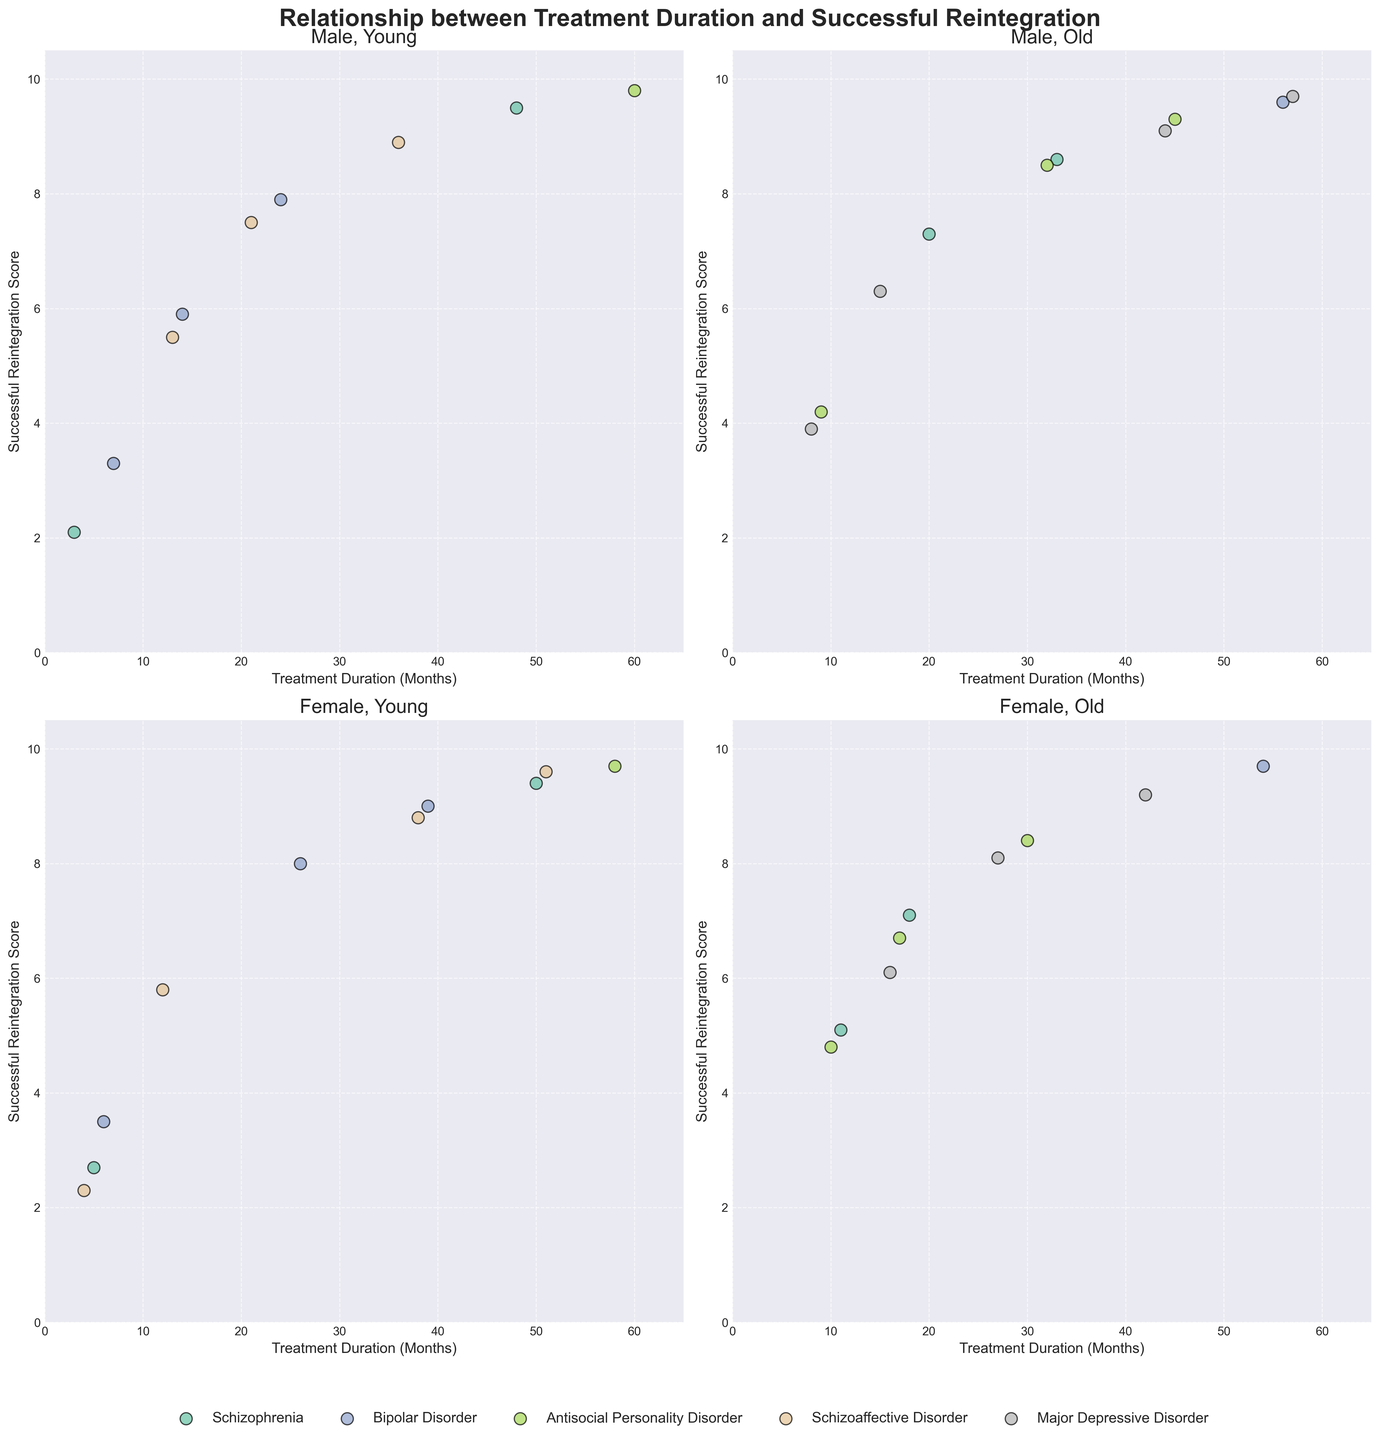Which age group for males shows a stronger correlation between treatment duration and reintegration success, Young or Old? Compare the spread and alignment of the data points from the male 'Young' and 'Old' subplots. The 'Old' age group in males shows a more consistent increase in reintegration success with longer treatment duration.
Answer: Old Comparing males and females in the Young age group, who has the highest reintegration score? Look at the highest points on the Young subplots for both males and females. The highest reintegration score in the male Young group is 9.7, and in the female Young group, it is also 9.7.
Answer: Both are equal For female patients, is there a significant difference in the successful reintegration score between Young and Old age groups for the same treatment duration? Examine overlapping treatment durations in the female 'Young' and 'Old' subplots to compare the reintegration scores. For example, at 9 months, the 'Young' female has a score of 4.2, while the 'Old' female at 8 months has a score of 8.0, indicating a significant difference.
Answer: Yes What is the overall trend of successful reintegration scores as treatment duration increases for the Old age group in both genders? Observe both subplots for the Old age group, noting the general direction of the data points along the x-axis. Both subplots show an increasing trend in reintegration scores with longer treatment duration.
Answer: Increase Which diagnosis shows the highest reintegration score for young female patients? Look for the highest data point in the young female subplot and identify its corresponding diagnosis. For young females, the highest score of 9.7 corresponds to Schizoaffective Disorder.
Answer: Schizoaffective Disorder Comparing the diagnoses represented in each subplot, which condition appears most frequently in the data? Count the occurrences of each diagnosis across all subplots. Schizophrenia appears most frequently in the data.
Answer: Schizophrenia Among patients with Antisocial Personality Disorder, do males or females have a higher maximum successful reintegration score? Identify the highest points for Antisocial Personality Disorder in both male and female subplots. The highest score for males is 9.8, while for females it is 9.7.
Answer: Males What is the average reintegration score for the Old female group? Sum the reintegration scores and divide by the number of data points for the 'Old' female subplot. Reintegration scores: 7.1, 8.4, 9.2, 9.5, 9.7, 9.6. Average = (7.1 + 8.4 + 9.2 + 9.5 + 9.7 + 9.6) / 6 = 8.9
Answer: 8.9 Does the reintegration score reach a plateau for young male patients after a certain treatment duration? Analyze the young male subplot for any plateau in scores as treatment duration increases. The scores generally increase without a clear plateau, suggesting continuous improvement.
Answer: No By how much does the reintegration score of young females increase between the shortest and longest treatment durations? Compare the scores at the shortest (3 months) and longest (60 months) durations for young females. The score increases from 2.1 to 9.8. The difference is 9.8 - 2.1 = 7.7
Answer: 7.7 